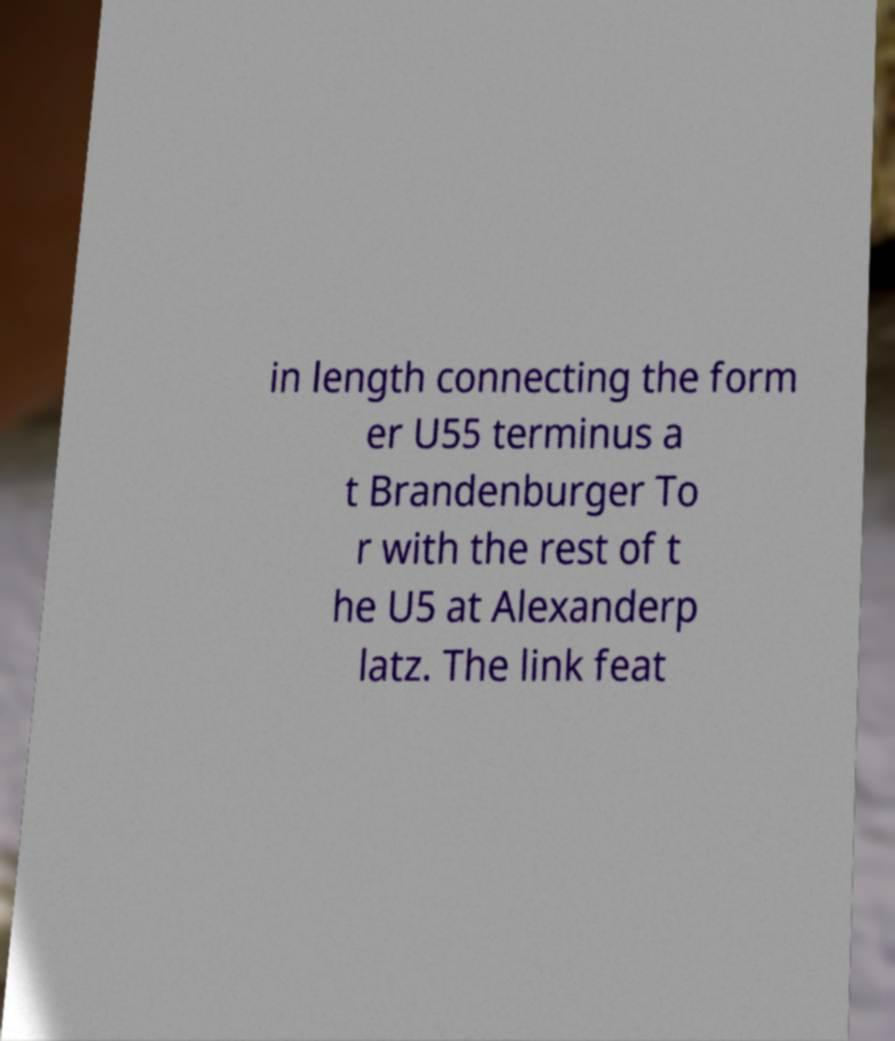Please read and relay the text visible in this image. What does it say? in length connecting the form er U55 terminus a t Brandenburger To r with the rest of t he U5 at Alexanderp latz. The link feat 